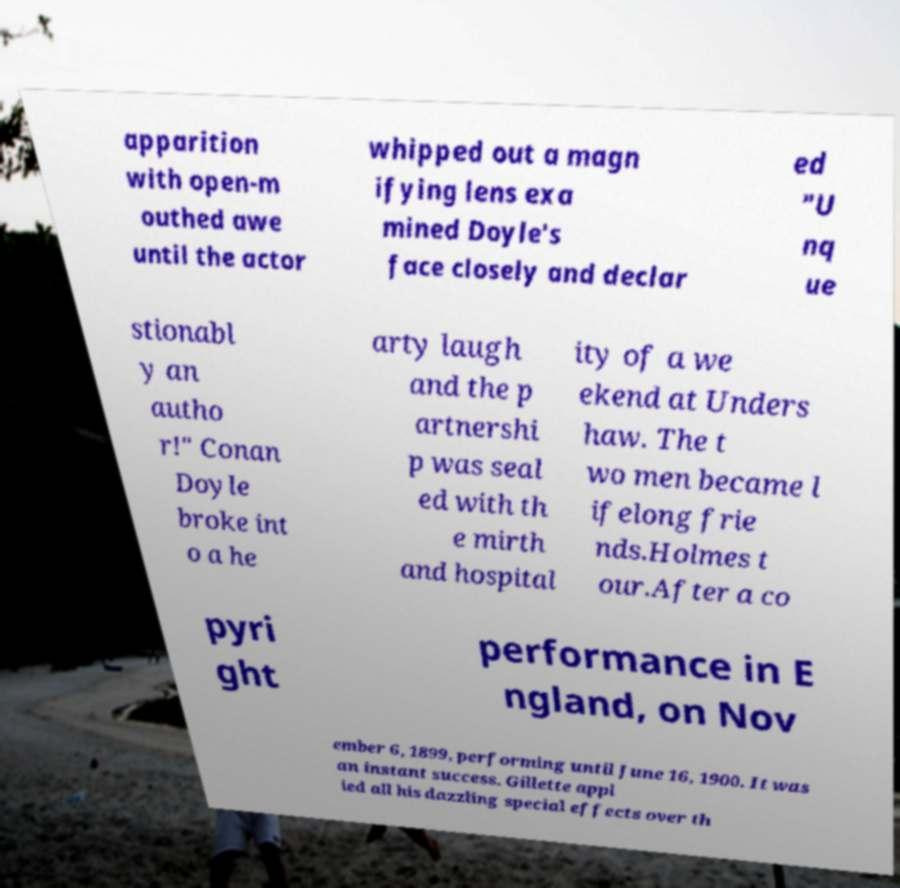Could you extract and type out the text from this image? apparition with open-m outhed awe until the actor whipped out a magn ifying lens exa mined Doyle's face closely and declar ed "U nq ue stionabl y an autho r!" Conan Doyle broke int o a he arty laugh and the p artnershi p was seal ed with th e mirth and hospital ity of a we ekend at Unders haw. The t wo men became l ifelong frie nds.Holmes t our.After a co pyri ght performance in E ngland, on Nov ember 6, 1899, performing until June 16, 1900. It was an instant success. Gillette appl ied all his dazzling special effects over th 